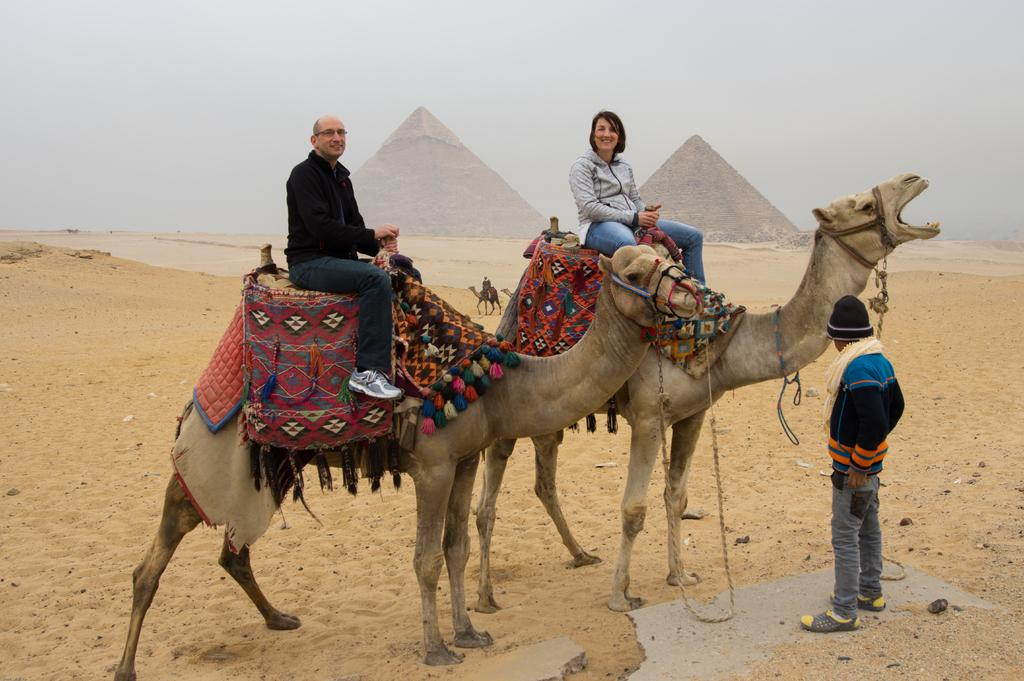How many camels are in the image? There are two camels in the image. What are the people in the image doing with the camels? A man and a woman are sitting on one of the camels. Who is standing in front of the camels? There is a man standing in front of the camels. What can be seen in the background of the image? There are two pyramids and two additional camels in the background of the image. What type of point is the camel trying to make in the image? Camels do not make points; they are animals. The image simply shows camels with people interacting with them. Is the camel in motion in the image? The camels in the image are not in motion; they are stationary. 